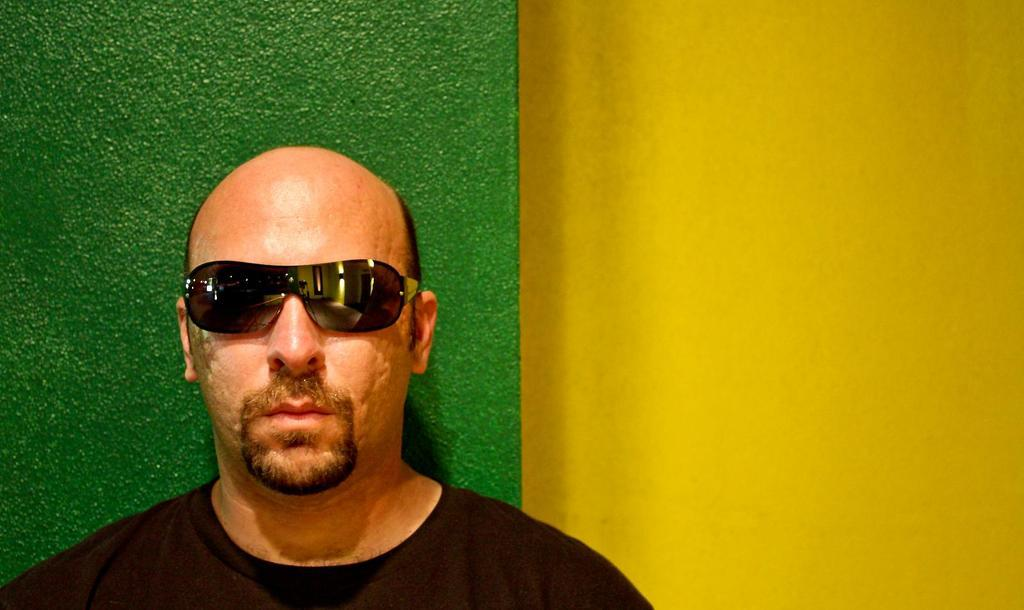What is the main subject of the image? There is a man standing in the image. Can you describe the man's appearance? The man is wearing glasses. What colors are present on the walls in the image? There is a yellow color wall on the right side of the image, and a green color wall behind the man. What type of stick is the man holding in the image? There is no stick present in the image; the man is not holding anything. What appliance is the man using in the image? There is no appliance present in the image; the man is simply standing. 